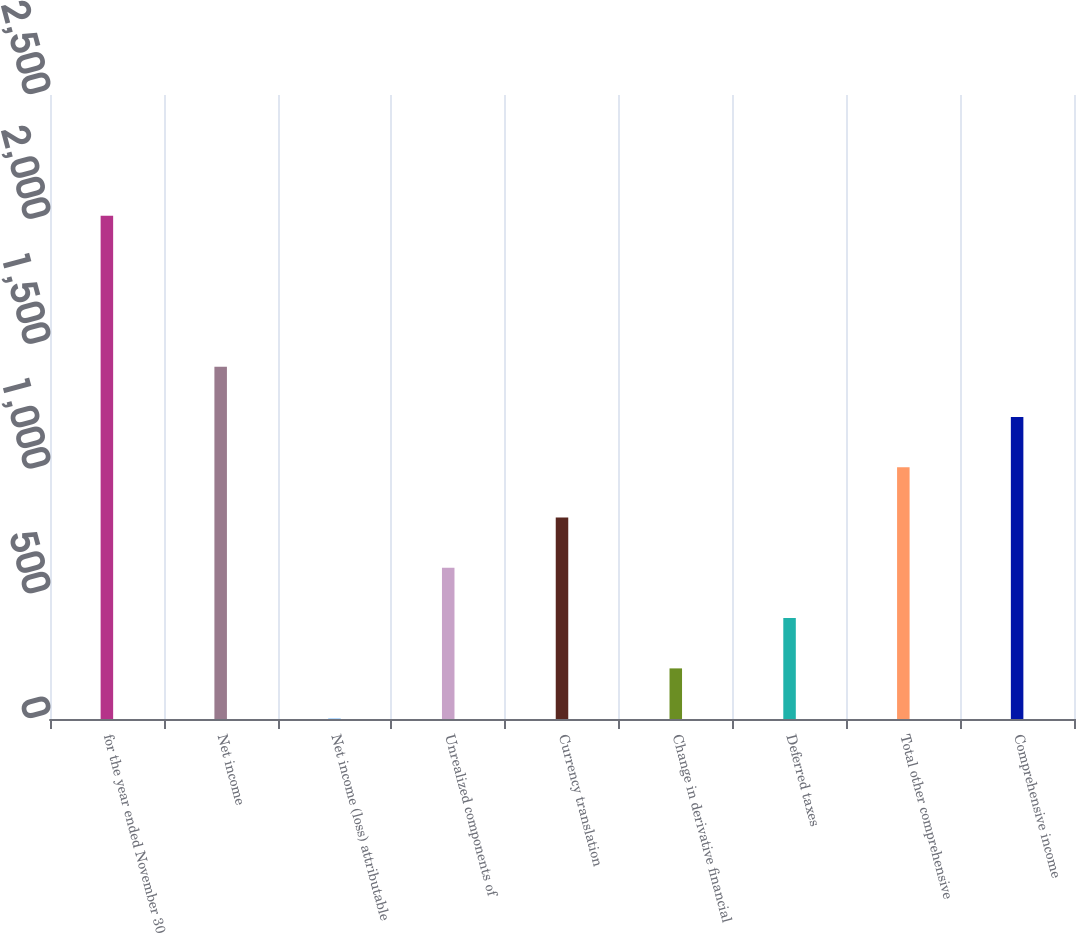Convert chart. <chart><loc_0><loc_0><loc_500><loc_500><bar_chart><fcel>for the year ended November 30<fcel>Net income<fcel>Net income (loss) attributable<fcel>Unrealized components of<fcel>Currency translation<fcel>Change in derivative financial<fcel>Deferred taxes<fcel>Total other comprehensive<fcel>Comprehensive income<nl><fcel>2016<fcel>1411.59<fcel>1.3<fcel>605.71<fcel>807.18<fcel>202.77<fcel>404.24<fcel>1008.65<fcel>1210.12<nl></chart> 